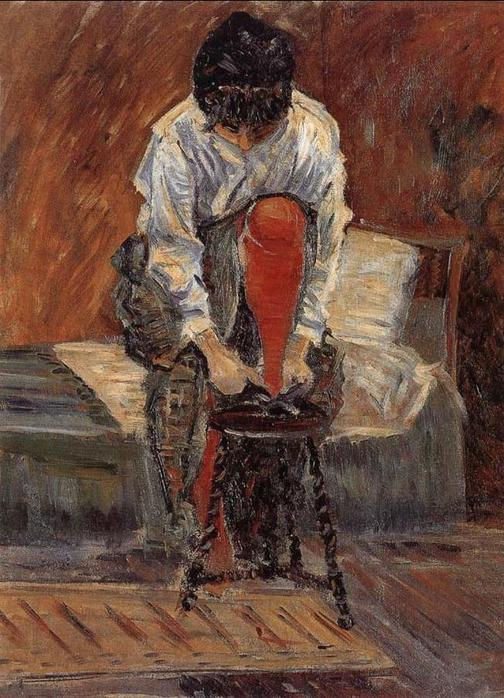Create a hypothetical conversation this woman might have after this moment. The woman lifts her head as her friend enters the room. 'Hey, you seem lost in thought,' her friend says warmly.
She smiles back, 'Just thinking about today's events. Work was exhausting, and I ran into Julie at the market.'
'Julie? How is she?' her friend inquires, pulling a chair to sit beside her.
'That's the thing,' she responds, 'she's going through such a tough time. I couldn't stop thinking about how overwhelmed she looked.'
They continue to chat, sharing their day's stories and providing comfort in each other's company. 